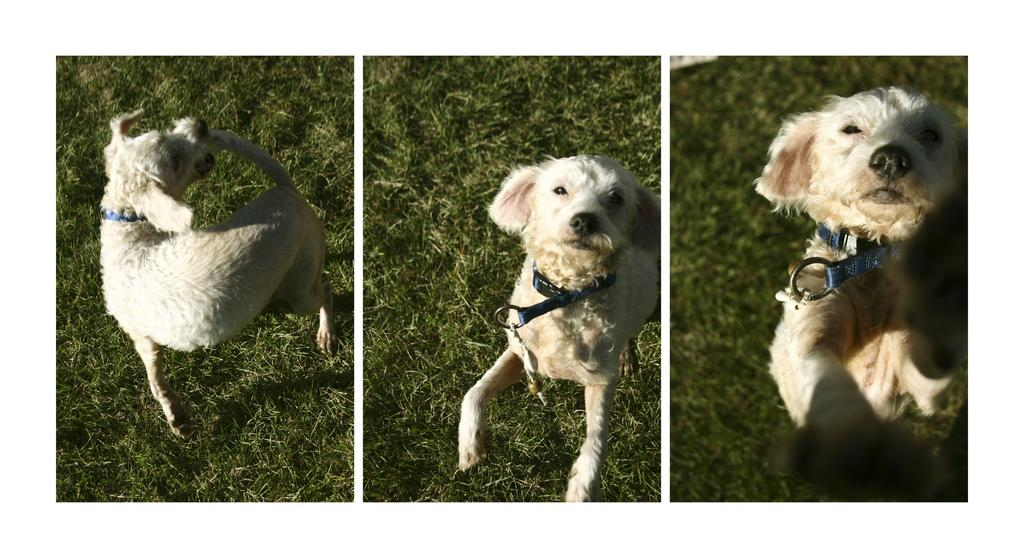What is the main subject of the image? The main subject of the image is a collage of dog pictures. What can be seen on the ground in the image? There is grass on the ground in the image. What color is the dog in the image? The dog in the image is white in color. What accessory is the dog wearing? The dog is wearing a blue belt. What type of liquid is being poured on the dog in the image? There is no liquid being poured on the dog in the image; it is a collage of dog pictures with a white dog wearing a blue belt. Can you see any keys in the image? There are no keys present in the image. 